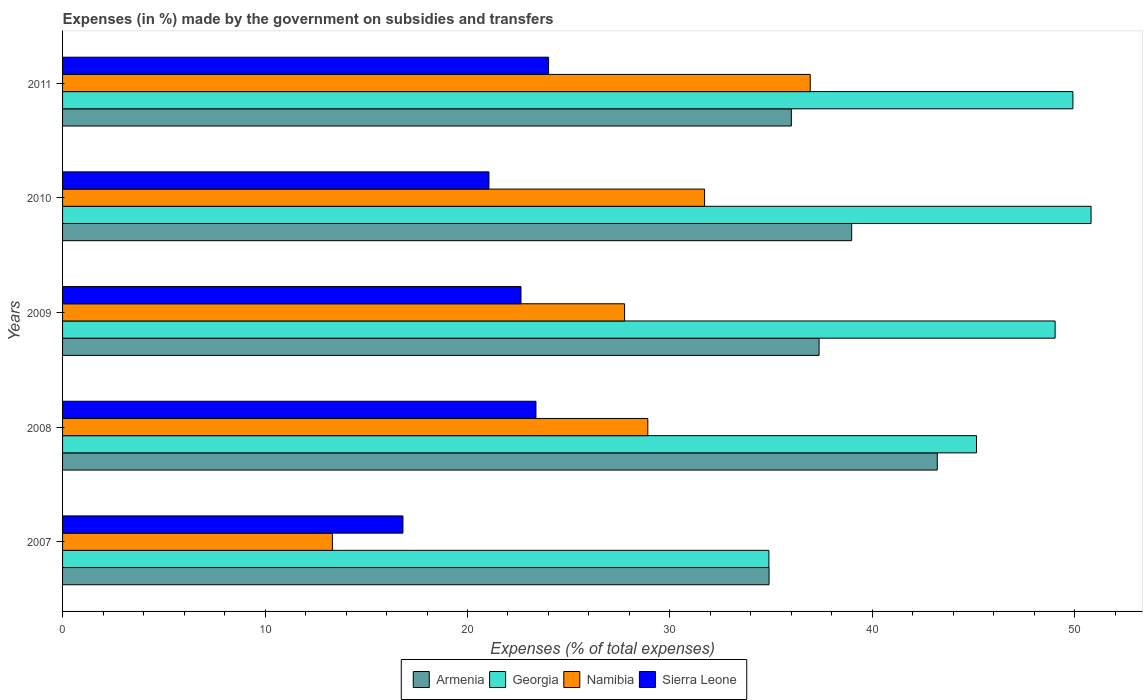How many groups of bars are there?
Give a very brief answer. 5. How many bars are there on the 2nd tick from the top?
Give a very brief answer. 4. What is the label of the 3rd group of bars from the top?
Your answer should be very brief. 2009. In how many cases, is the number of bars for a given year not equal to the number of legend labels?
Give a very brief answer. 0. What is the percentage of expenses made by the government on subsidies and transfers in Georgia in 2007?
Give a very brief answer. 34.89. Across all years, what is the maximum percentage of expenses made by the government on subsidies and transfers in Armenia?
Offer a terse response. 43.2. Across all years, what is the minimum percentage of expenses made by the government on subsidies and transfers in Namibia?
Your answer should be very brief. 13.33. In which year was the percentage of expenses made by the government on subsidies and transfers in Sierra Leone maximum?
Make the answer very short. 2011. In which year was the percentage of expenses made by the government on subsidies and transfers in Namibia minimum?
Ensure brevity in your answer.  2007. What is the total percentage of expenses made by the government on subsidies and transfers in Sierra Leone in the graph?
Keep it short and to the point. 107.9. What is the difference between the percentage of expenses made by the government on subsidies and transfers in Armenia in 2008 and that in 2010?
Provide a short and direct response. 4.23. What is the difference between the percentage of expenses made by the government on subsidies and transfers in Sierra Leone in 2009 and the percentage of expenses made by the government on subsidies and transfers in Armenia in 2008?
Your answer should be compact. -20.56. What is the average percentage of expenses made by the government on subsidies and transfers in Namibia per year?
Keep it short and to the point. 27.73. In the year 2008, what is the difference between the percentage of expenses made by the government on subsidies and transfers in Namibia and percentage of expenses made by the government on subsidies and transfers in Sierra Leone?
Ensure brevity in your answer.  5.52. In how many years, is the percentage of expenses made by the government on subsidies and transfers in Georgia greater than 24 %?
Provide a succinct answer. 5. What is the ratio of the percentage of expenses made by the government on subsidies and transfers in Georgia in 2007 to that in 2011?
Offer a very short reply. 0.7. What is the difference between the highest and the second highest percentage of expenses made by the government on subsidies and transfers in Sierra Leone?
Keep it short and to the point. 0.62. What is the difference between the highest and the lowest percentage of expenses made by the government on subsidies and transfers in Namibia?
Make the answer very short. 23.6. In how many years, is the percentage of expenses made by the government on subsidies and transfers in Armenia greater than the average percentage of expenses made by the government on subsidies and transfers in Armenia taken over all years?
Keep it short and to the point. 2. What does the 3rd bar from the top in 2008 represents?
Your answer should be compact. Georgia. What does the 1st bar from the bottom in 2009 represents?
Offer a terse response. Armenia. Is it the case that in every year, the sum of the percentage of expenses made by the government on subsidies and transfers in Namibia and percentage of expenses made by the government on subsidies and transfers in Georgia is greater than the percentage of expenses made by the government on subsidies and transfers in Armenia?
Your answer should be very brief. Yes. How many bars are there?
Provide a succinct answer. 20. Are all the bars in the graph horizontal?
Provide a succinct answer. Yes. What is the difference between two consecutive major ticks on the X-axis?
Offer a very short reply. 10. Does the graph contain grids?
Offer a terse response. No. Where does the legend appear in the graph?
Provide a short and direct response. Bottom center. What is the title of the graph?
Your answer should be very brief. Expenses (in %) made by the government on subsidies and transfers. What is the label or title of the X-axis?
Offer a very short reply. Expenses (% of total expenses). What is the label or title of the Y-axis?
Offer a terse response. Years. What is the Expenses (% of total expenses) in Armenia in 2007?
Your answer should be very brief. 34.89. What is the Expenses (% of total expenses) of Georgia in 2007?
Ensure brevity in your answer.  34.89. What is the Expenses (% of total expenses) of Namibia in 2007?
Your response must be concise. 13.33. What is the Expenses (% of total expenses) of Sierra Leone in 2007?
Ensure brevity in your answer.  16.81. What is the Expenses (% of total expenses) of Armenia in 2008?
Offer a terse response. 43.2. What is the Expenses (% of total expenses) of Georgia in 2008?
Offer a terse response. 45.14. What is the Expenses (% of total expenses) in Namibia in 2008?
Offer a very short reply. 28.91. What is the Expenses (% of total expenses) in Sierra Leone in 2008?
Offer a terse response. 23.38. What is the Expenses (% of total expenses) in Armenia in 2009?
Offer a terse response. 37.37. What is the Expenses (% of total expenses) in Georgia in 2009?
Give a very brief answer. 49.03. What is the Expenses (% of total expenses) in Namibia in 2009?
Provide a short and direct response. 27.76. What is the Expenses (% of total expenses) of Sierra Leone in 2009?
Make the answer very short. 22.64. What is the Expenses (% of total expenses) in Armenia in 2010?
Provide a short and direct response. 38.98. What is the Expenses (% of total expenses) in Georgia in 2010?
Give a very brief answer. 50.8. What is the Expenses (% of total expenses) in Namibia in 2010?
Keep it short and to the point. 31.71. What is the Expenses (% of total expenses) of Sierra Leone in 2010?
Your answer should be compact. 21.06. What is the Expenses (% of total expenses) in Armenia in 2011?
Ensure brevity in your answer.  36. What is the Expenses (% of total expenses) in Georgia in 2011?
Provide a short and direct response. 49.9. What is the Expenses (% of total expenses) in Namibia in 2011?
Give a very brief answer. 36.93. What is the Expenses (% of total expenses) in Sierra Leone in 2011?
Provide a short and direct response. 24.01. Across all years, what is the maximum Expenses (% of total expenses) of Armenia?
Your answer should be compact. 43.2. Across all years, what is the maximum Expenses (% of total expenses) in Georgia?
Provide a succinct answer. 50.8. Across all years, what is the maximum Expenses (% of total expenses) in Namibia?
Your response must be concise. 36.93. Across all years, what is the maximum Expenses (% of total expenses) of Sierra Leone?
Give a very brief answer. 24.01. Across all years, what is the minimum Expenses (% of total expenses) of Armenia?
Provide a short and direct response. 34.89. Across all years, what is the minimum Expenses (% of total expenses) in Georgia?
Offer a very short reply. 34.89. Across all years, what is the minimum Expenses (% of total expenses) in Namibia?
Ensure brevity in your answer.  13.33. Across all years, what is the minimum Expenses (% of total expenses) of Sierra Leone?
Your answer should be compact. 16.81. What is the total Expenses (% of total expenses) of Armenia in the graph?
Provide a succinct answer. 190.44. What is the total Expenses (% of total expenses) of Georgia in the graph?
Provide a succinct answer. 229.76. What is the total Expenses (% of total expenses) of Namibia in the graph?
Give a very brief answer. 138.63. What is the total Expenses (% of total expenses) of Sierra Leone in the graph?
Provide a succinct answer. 107.9. What is the difference between the Expenses (% of total expenses) of Armenia in 2007 and that in 2008?
Your response must be concise. -8.31. What is the difference between the Expenses (% of total expenses) in Georgia in 2007 and that in 2008?
Your answer should be compact. -10.26. What is the difference between the Expenses (% of total expenses) in Namibia in 2007 and that in 2008?
Provide a short and direct response. -15.58. What is the difference between the Expenses (% of total expenses) of Sierra Leone in 2007 and that in 2008?
Your answer should be compact. -6.57. What is the difference between the Expenses (% of total expenses) of Armenia in 2007 and that in 2009?
Provide a succinct answer. -2.47. What is the difference between the Expenses (% of total expenses) of Georgia in 2007 and that in 2009?
Provide a succinct answer. -14.14. What is the difference between the Expenses (% of total expenses) in Namibia in 2007 and that in 2009?
Keep it short and to the point. -14.43. What is the difference between the Expenses (% of total expenses) of Sierra Leone in 2007 and that in 2009?
Keep it short and to the point. -5.83. What is the difference between the Expenses (% of total expenses) of Armenia in 2007 and that in 2010?
Your answer should be very brief. -4.08. What is the difference between the Expenses (% of total expenses) of Georgia in 2007 and that in 2010?
Give a very brief answer. -15.91. What is the difference between the Expenses (% of total expenses) of Namibia in 2007 and that in 2010?
Your response must be concise. -18.38. What is the difference between the Expenses (% of total expenses) in Sierra Leone in 2007 and that in 2010?
Give a very brief answer. -4.25. What is the difference between the Expenses (% of total expenses) in Armenia in 2007 and that in 2011?
Offer a very short reply. -1.1. What is the difference between the Expenses (% of total expenses) of Georgia in 2007 and that in 2011?
Your response must be concise. -15.02. What is the difference between the Expenses (% of total expenses) of Namibia in 2007 and that in 2011?
Provide a short and direct response. -23.6. What is the difference between the Expenses (% of total expenses) of Sierra Leone in 2007 and that in 2011?
Provide a succinct answer. -7.19. What is the difference between the Expenses (% of total expenses) of Armenia in 2008 and that in 2009?
Give a very brief answer. 5.84. What is the difference between the Expenses (% of total expenses) in Georgia in 2008 and that in 2009?
Offer a terse response. -3.88. What is the difference between the Expenses (% of total expenses) of Namibia in 2008 and that in 2009?
Your answer should be very brief. 1.15. What is the difference between the Expenses (% of total expenses) of Sierra Leone in 2008 and that in 2009?
Ensure brevity in your answer.  0.74. What is the difference between the Expenses (% of total expenses) of Armenia in 2008 and that in 2010?
Provide a succinct answer. 4.23. What is the difference between the Expenses (% of total expenses) of Georgia in 2008 and that in 2010?
Keep it short and to the point. -5.66. What is the difference between the Expenses (% of total expenses) in Namibia in 2008 and that in 2010?
Offer a terse response. -2.8. What is the difference between the Expenses (% of total expenses) in Sierra Leone in 2008 and that in 2010?
Offer a terse response. 2.32. What is the difference between the Expenses (% of total expenses) of Armenia in 2008 and that in 2011?
Make the answer very short. 7.21. What is the difference between the Expenses (% of total expenses) of Georgia in 2008 and that in 2011?
Your response must be concise. -4.76. What is the difference between the Expenses (% of total expenses) in Namibia in 2008 and that in 2011?
Ensure brevity in your answer.  -8.02. What is the difference between the Expenses (% of total expenses) of Sierra Leone in 2008 and that in 2011?
Your response must be concise. -0.62. What is the difference between the Expenses (% of total expenses) of Armenia in 2009 and that in 2010?
Your response must be concise. -1.61. What is the difference between the Expenses (% of total expenses) of Georgia in 2009 and that in 2010?
Make the answer very short. -1.78. What is the difference between the Expenses (% of total expenses) in Namibia in 2009 and that in 2010?
Your answer should be compact. -3.95. What is the difference between the Expenses (% of total expenses) of Sierra Leone in 2009 and that in 2010?
Your response must be concise. 1.58. What is the difference between the Expenses (% of total expenses) of Armenia in 2009 and that in 2011?
Offer a very short reply. 1.37. What is the difference between the Expenses (% of total expenses) of Georgia in 2009 and that in 2011?
Make the answer very short. -0.88. What is the difference between the Expenses (% of total expenses) in Namibia in 2009 and that in 2011?
Offer a terse response. -9.17. What is the difference between the Expenses (% of total expenses) in Sierra Leone in 2009 and that in 2011?
Provide a succinct answer. -1.36. What is the difference between the Expenses (% of total expenses) in Armenia in 2010 and that in 2011?
Ensure brevity in your answer.  2.98. What is the difference between the Expenses (% of total expenses) in Georgia in 2010 and that in 2011?
Provide a succinct answer. 0.9. What is the difference between the Expenses (% of total expenses) in Namibia in 2010 and that in 2011?
Make the answer very short. -5.22. What is the difference between the Expenses (% of total expenses) in Sierra Leone in 2010 and that in 2011?
Give a very brief answer. -2.95. What is the difference between the Expenses (% of total expenses) of Armenia in 2007 and the Expenses (% of total expenses) of Georgia in 2008?
Your response must be concise. -10.25. What is the difference between the Expenses (% of total expenses) of Armenia in 2007 and the Expenses (% of total expenses) of Namibia in 2008?
Your response must be concise. 5.99. What is the difference between the Expenses (% of total expenses) of Armenia in 2007 and the Expenses (% of total expenses) of Sierra Leone in 2008?
Keep it short and to the point. 11.51. What is the difference between the Expenses (% of total expenses) of Georgia in 2007 and the Expenses (% of total expenses) of Namibia in 2008?
Ensure brevity in your answer.  5.98. What is the difference between the Expenses (% of total expenses) of Georgia in 2007 and the Expenses (% of total expenses) of Sierra Leone in 2008?
Offer a terse response. 11.5. What is the difference between the Expenses (% of total expenses) in Namibia in 2007 and the Expenses (% of total expenses) in Sierra Leone in 2008?
Offer a terse response. -10.06. What is the difference between the Expenses (% of total expenses) of Armenia in 2007 and the Expenses (% of total expenses) of Georgia in 2009?
Give a very brief answer. -14.13. What is the difference between the Expenses (% of total expenses) in Armenia in 2007 and the Expenses (% of total expenses) in Namibia in 2009?
Give a very brief answer. 7.13. What is the difference between the Expenses (% of total expenses) of Armenia in 2007 and the Expenses (% of total expenses) of Sierra Leone in 2009?
Provide a succinct answer. 12.25. What is the difference between the Expenses (% of total expenses) in Georgia in 2007 and the Expenses (% of total expenses) in Namibia in 2009?
Keep it short and to the point. 7.13. What is the difference between the Expenses (% of total expenses) in Georgia in 2007 and the Expenses (% of total expenses) in Sierra Leone in 2009?
Make the answer very short. 12.25. What is the difference between the Expenses (% of total expenses) of Namibia in 2007 and the Expenses (% of total expenses) of Sierra Leone in 2009?
Offer a terse response. -9.31. What is the difference between the Expenses (% of total expenses) in Armenia in 2007 and the Expenses (% of total expenses) in Georgia in 2010?
Offer a very short reply. -15.91. What is the difference between the Expenses (% of total expenses) in Armenia in 2007 and the Expenses (% of total expenses) in Namibia in 2010?
Make the answer very short. 3.18. What is the difference between the Expenses (% of total expenses) in Armenia in 2007 and the Expenses (% of total expenses) in Sierra Leone in 2010?
Provide a short and direct response. 13.84. What is the difference between the Expenses (% of total expenses) of Georgia in 2007 and the Expenses (% of total expenses) of Namibia in 2010?
Your answer should be very brief. 3.18. What is the difference between the Expenses (% of total expenses) of Georgia in 2007 and the Expenses (% of total expenses) of Sierra Leone in 2010?
Make the answer very short. 13.83. What is the difference between the Expenses (% of total expenses) of Namibia in 2007 and the Expenses (% of total expenses) of Sierra Leone in 2010?
Keep it short and to the point. -7.73. What is the difference between the Expenses (% of total expenses) of Armenia in 2007 and the Expenses (% of total expenses) of Georgia in 2011?
Keep it short and to the point. -15.01. What is the difference between the Expenses (% of total expenses) of Armenia in 2007 and the Expenses (% of total expenses) of Namibia in 2011?
Make the answer very short. -2.03. What is the difference between the Expenses (% of total expenses) of Armenia in 2007 and the Expenses (% of total expenses) of Sierra Leone in 2011?
Provide a short and direct response. 10.89. What is the difference between the Expenses (% of total expenses) in Georgia in 2007 and the Expenses (% of total expenses) in Namibia in 2011?
Offer a very short reply. -2.04. What is the difference between the Expenses (% of total expenses) of Georgia in 2007 and the Expenses (% of total expenses) of Sierra Leone in 2011?
Your response must be concise. 10.88. What is the difference between the Expenses (% of total expenses) of Namibia in 2007 and the Expenses (% of total expenses) of Sierra Leone in 2011?
Make the answer very short. -10.68. What is the difference between the Expenses (% of total expenses) of Armenia in 2008 and the Expenses (% of total expenses) of Georgia in 2009?
Give a very brief answer. -5.82. What is the difference between the Expenses (% of total expenses) of Armenia in 2008 and the Expenses (% of total expenses) of Namibia in 2009?
Provide a succinct answer. 15.44. What is the difference between the Expenses (% of total expenses) in Armenia in 2008 and the Expenses (% of total expenses) in Sierra Leone in 2009?
Give a very brief answer. 20.56. What is the difference between the Expenses (% of total expenses) of Georgia in 2008 and the Expenses (% of total expenses) of Namibia in 2009?
Ensure brevity in your answer.  17.38. What is the difference between the Expenses (% of total expenses) of Georgia in 2008 and the Expenses (% of total expenses) of Sierra Leone in 2009?
Make the answer very short. 22.5. What is the difference between the Expenses (% of total expenses) in Namibia in 2008 and the Expenses (% of total expenses) in Sierra Leone in 2009?
Your answer should be compact. 6.26. What is the difference between the Expenses (% of total expenses) in Armenia in 2008 and the Expenses (% of total expenses) in Georgia in 2010?
Offer a terse response. -7.6. What is the difference between the Expenses (% of total expenses) in Armenia in 2008 and the Expenses (% of total expenses) in Namibia in 2010?
Make the answer very short. 11.49. What is the difference between the Expenses (% of total expenses) of Armenia in 2008 and the Expenses (% of total expenses) of Sierra Leone in 2010?
Offer a terse response. 22.14. What is the difference between the Expenses (% of total expenses) of Georgia in 2008 and the Expenses (% of total expenses) of Namibia in 2010?
Provide a short and direct response. 13.43. What is the difference between the Expenses (% of total expenses) in Georgia in 2008 and the Expenses (% of total expenses) in Sierra Leone in 2010?
Your response must be concise. 24.08. What is the difference between the Expenses (% of total expenses) in Namibia in 2008 and the Expenses (% of total expenses) in Sierra Leone in 2010?
Your answer should be compact. 7.85. What is the difference between the Expenses (% of total expenses) in Armenia in 2008 and the Expenses (% of total expenses) in Georgia in 2011?
Offer a very short reply. -6.7. What is the difference between the Expenses (% of total expenses) of Armenia in 2008 and the Expenses (% of total expenses) of Namibia in 2011?
Your response must be concise. 6.27. What is the difference between the Expenses (% of total expenses) in Armenia in 2008 and the Expenses (% of total expenses) in Sierra Leone in 2011?
Give a very brief answer. 19.2. What is the difference between the Expenses (% of total expenses) of Georgia in 2008 and the Expenses (% of total expenses) of Namibia in 2011?
Make the answer very short. 8.21. What is the difference between the Expenses (% of total expenses) in Georgia in 2008 and the Expenses (% of total expenses) in Sierra Leone in 2011?
Give a very brief answer. 21.14. What is the difference between the Expenses (% of total expenses) of Namibia in 2008 and the Expenses (% of total expenses) of Sierra Leone in 2011?
Ensure brevity in your answer.  4.9. What is the difference between the Expenses (% of total expenses) in Armenia in 2009 and the Expenses (% of total expenses) in Georgia in 2010?
Ensure brevity in your answer.  -13.43. What is the difference between the Expenses (% of total expenses) in Armenia in 2009 and the Expenses (% of total expenses) in Namibia in 2010?
Provide a short and direct response. 5.66. What is the difference between the Expenses (% of total expenses) in Armenia in 2009 and the Expenses (% of total expenses) in Sierra Leone in 2010?
Offer a very short reply. 16.31. What is the difference between the Expenses (% of total expenses) of Georgia in 2009 and the Expenses (% of total expenses) of Namibia in 2010?
Offer a terse response. 17.31. What is the difference between the Expenses (% of total expenses) of Georgia in 2009 and the Expenses (% of total expenses) of Sierra Leone in 2010?
Give a very brief answer. 27.97. What is the difference between the Expenses (% of total expenses) of Namibia in 2009 and the Expenses (% of total expenses) of Sierra Leone in 2010?
Give a very brief answer. 6.7. What is the difference between the Expenses (% of total expenses) of Armenia in 2009 and the Expenses (% of total expenses) of Georgia in 2011?
Keep it short and to the point. -12.54. What is the difference between the Expenses (% of total expenses) of Armenia in 2009 and the Expenses (% of total expenses) of Namibia in 2011?
Ensure brevity in your answer.  0.44. What is the difference between the Expenses (% of total expenses) of Armenia in 2009 and the Expenses (% of total expenses) of Sierra Leone in 2011?
Offer a terse response. 13.36. What is the difference between the Expenses (% of total expenses) in Georgia in 2009 and the Expenses (% of total expenses) in Namibia in 2011?
Provide a short and direct response. 12.1. What is the difference between the Expenses (% of total expenses) in Georgia in 2009 and the Expenses (% of total expenses) in Sierra Leone in 2011?
Provide a succinct answer. 25.02. What is the difference between the Expenses (% of total expenses) of Namibia in 2009 and the Expenses (% of total expenses) of Sierra Leone in 2011?
Ensure brevity in your answer.  3.75. What is the difference between the Expenses (% of total expenses) in Armenia in 2010 and the Expenses (% of total expenses) in Georgia in 2011?
Your answer should be compact. -10.93. What is the difference between the Expenses (% of total expenses) in Armenia in 2010 and the Expenses (% of total expenses) in Namibia in 2011?
Your answer should be very brief. 2.05. What is the difference between the Expenses (% of total expenses) of Armenia in 2010 and the Expenses (% of total expenses) of Sierra Leone in 2011?
Your answer should be very brief. 14.97. What is the difference between the Expenses (% of total expenses) of Georgia in 2010 and the Expenses (% of total expenses) of Namibia in 2011?
Offer a very short reply. 13.87. What is the difference between the Expenses (% of total expenses) of Georgia in 2010 and the Expenses (% of total expenses) of Sierra Leone in 2011?
Offer a very short reply. 26.79. What is the difference between the Expenses (% of total expenses) of Namibia in 2010 and the Expenses (% of total expenses) of Sierra Leone in 2011?
Give a very brief answer. 7.7. What is the average Expenses (% of total expenses) of Armenia per year?
Your answer should be compact. 38.09. What is the average Expenses (% of total expenses) in Georgia per year?
Offer a terse response. 45.95. What is the average Expenses (% of total expenses) of Namibia per year?
Your answer should be compact. 27.73. What is the average Expenses (% of total expenses) in Sierra Leone per year?
Your response must be concise. 21.58. In the year 2007, what is the difference between the Expenses (% of total expenses) in Armenia and Expenses (% of total expenses) in Georgia?
Offer a very short reply. 0.01. In the year 2007, what is the difference between the Expenses (% of total expenses) in Armenia and Expenses (% of total expenses) in Namibia?
Keep it short and to the point. 21.57. In the year 2007, what is the difference between the Expenses (% of total expenses) in Armenia and Expenses (% of total expenses) in Sierra Leone?
Ensure brevity in your answer.  18.08. In the year 2007, what is the difference between the Expenses (% of total expenses) in Georgia and Expenses (% of total expenses) in Namibia?
Provide a succinct answer. 21.56. In the year 2007, what is the difference between the Expenses (% of total expenses) of Georgia and Expenses (% of total expenses) of Sierra Leone?
Offer a very short reply. 18.07. In the year 2007, what is the difference between the Expenses (% of total expenses) of Namibia and Expenses (% of total expenses) of Sierra Leone?
Your answer should be compact. -3.48. In the year 2008, what is the difference between the Expenses (% of total expenses) of Armenia and Expenses (% of total expenses) of Georgia?
Your answer should be compact. -1.94. In the year 2008, what is the difference between the Expenses (% of total expenses) in Armenia and Expenses (% of total expenses) in Namibia?
Your answer should be compact. 14.3. In the year 2008, what is the difference between the Expenses (% of total expenses) of Armenia and Expenses (% of total expenses) of Sierra Leone?
Offer a very short reply. 19.82. In the year 2008, what is the difference between the Expenses (% of total expenses) of Georgia and Expenses (% of total expenses) of Namibia?
Provide a succinct answer. 16.24. In the year 2008, what is the difference between the Expenses (% of total expenses) of Georgia and Expenses (% of total expenses) of Sierra Leone?
Provide a short and direct response. 21.76. In the year 2008, what is the difference between the Expenses (% of total expenses) of Namibia and Expenses (% of total expenses) of Sierra Leone?
Offer a terse response. 5.52. In the year 2009, what is the difference between the Expenses (% of total expenses) of Armenia and Expenses (% of total expenses) of Georgia?
Your answer should be compact. -11.66. In the year 2009, what is the difference between the Expenses (% of total expenses) of Armenia and Expenses (% of total expenses) of Namibia?
Your response must be concise. 9.61. In the year 2009, what is the difference between the Expenses (% of total expenses) in Armenia and Expenses (% of total expenses) in Sierra Leone?
Make the answer very short. 14.72. In the year 2009, what is the difference between the Expenses (% of total expenses) in Georgia and Expenses (% of total expenses) in Namibia?
Your answer should be very brief. 21.27. In the year 2009, what is the difference between the Expenses (% of total expenses) of Georgia and Expenses (% of total expenses) of Sierra Leone?
Ensure brevity in your answer.  26.38. In the year 2009, what is the difference between the Expenses (% of total expenses) in Namibia and Expenses (% of total expenses) in Sierra Leone?
Your answer should be compact. 5.12. In the year 2010, what is the difference between the Expenses (% of total expenses) in Armenia and Expenses (% of total expenses) in Georgia?
Offer a very short reply. -11.82. In the year 2010, what is the difference between the Expenses (% of total expenses) of Armenia and Expenses (% of total expenses) of Namibia?
Your answer should be compact. 7.27. In the year 2010, what is the difference between the Expenses (% of total expenses) in Armenia and Expenses (% of total expenses) in Sierra Leone?
Offer a terse response. 17.92. In the year 2010, what is the difference between the Expenses (% of total expenses) in Georgia and Expenses (% of total expenses) in Namibia?
Your answer should be compact. 19.09. In the year 2010, what is the difference between the Expenses (% of total expenses) of Georgia and Expenses (% of total expenses) of Sierra Leone?
Keep it short and to the point. 29.74. In the year 2010, what is the difference between the Expenses (% of total expenses) of Namibia and Expenses (% of total expenses) of Sierra Leone?
Your answer should be compact. 10.65. In the year 2011, what is the difference between the Expenses (% of total expenses) of Armenia and Expenses (% of total expenses) of Georgia?
Provide a succinct answer. -13.91. In the year 2011, what is the difference between the Expenses (% of total expenses) of Armenia and Expenses (% of total expenses) of Namibia?
Keep it short and to the point. -0.93. In the year 2011, what is the difference between the Expenses (% of total expenses) in Armenia and Expenses (% of total expenses) in Sierra Leone?
Provide a succinct answer. 11.99. In the year 2011, what is the difference between the Expenses (% of total expenses) of Georgia and Expenses (% of total expenses) of Namibia?
Provide a succinct answer. 12.97. In the year 2011, what is the difference between the Expenses (% of total expenses) in Georgia and Expenses (% of total expenses) in Sierra Leone?
Offer a terse response. 25.9. In the year 2011, what is the difference between the Expenses (% of total expenses) in Namibia and Expenses (% of total expenses) in Sierra Leone?
Your response must be concise. 12.92. What is the ratio of the Expenses (% of total expenses) of Armenia in 2007 to that in 2008?
Provide a succinct answer. 0.81. What is the ratio of the Expenses (% of total expenses) of Georgia in 2007 to that in 2008?
Ensure brevity in your answer.  0.77. What is the ratio of the Expenses (% of total expenses) in Namibia in 2007 to that in 2008?
Offer a very short reply. 0.46. What is the ratio of the Expenses (% of total expenses) in Sierra Leone in 2007 to that in 2008?
Give a very brief answer. 0.72. What is the ratio of the Expenses (% of total expenses) in Armenia in 2007 to that in 2009?
Provide a succinct answer. 0.93. What is the ratio of the Expenses (% of total expenses) in Georgia in 2007 to that in 2009?
Your answer should be very brief. 0.71. What is the ratio of the Expenses (% of total expenses) in Namibia in 2007 to that in 2009?
Give a very brief answer. 0.48. What is the ratio of the Expenses (% of total expenses) of Sierra Leone in 2007 to that in 2009?
Provide a short and direct response. 0.74. What is the ratio of the Expenses (% of total expenses) of Armenia in 2007 to that in 2010?
Offer a terse response. 0.9. What is the ratio of the Expenses (% of total expenses) in Georgia in 2007 to that in 2010?
Your answer should be compact. 0.69. What is the ratio of the Expenses (% of total expenses) in Namibia in 2007 to that in 2010?
Give a very brief answer. 0.42. What is the ratio of the Expenses (% of total expenses) in Sierra Leone in 2007 to that in 2010?
Ensure brevity in your answer.  0.8. What is the ratio of the Expenses (% of total expenses) of Armenia in 2007 to that in 2011?
Your response must be concise. 0.97. What is the ratio of the Expenses (% of total expenses) of Georgia in 2007 to that in 2011?
Your response must be concise. 0.7. What is the ratio of the Expenses (% of total expenses) of Namibia in 2007 to that in 2011?
Give a very brief answer. 0.36. What is the ratio of the Expenses (% of total expenses) of Sierra Leone in 2007 to that in 2011?
Provide a short and direct response. 0.7. What is the ratio of the Expenses (% of total expenses) of Armenia in 2008 to that in 2009?
Ensure brevity in your answer.  1.16. What is the ratio of the Expenses (% of total expenses) in Georgia in 2008 to that in 2009?
Your response must be concise. 0.92. What is the ratio of the Expenses (% of total expenses) of Namibia in 2008 to that in 2009?
Your response must be concise. 1.04. What is the ratio of the Expenses (% of total expenses) in Sierra Leone in 2008 to that in 2009?
Your answer should be compact. 1.03. What is the ratio of the Expenses (% of total expenses) of Armenia in 2008 to that in 2010?
Give a very brief answer. 1.11. What is the ratio of the Expenses (% of total expenses) of Georgia in 2008 to that in 2010?
Ensure brevity in your answer.  0.89. What is the ratio of the Expenses (% of total expenses) of Namibia in 2008 to that in 2010?
Give a very brief answer. 0.91. What is the ratio of the Expenses (% of total expenses) in Sierra Leone in 2008 to that in 2010?
Give a very brief answer. 1.11. What is the ratio of the Expenses (% of total expenses) of Armenia in 2008 to that in 2011?
Your answer should be very brief. 1.2. What is the ratio of the Expenses (% of total expenses) of Georgia in 2008 to that in 2011?
Your answer should be compact. 0.9. What is the ratio of the Expenses (% of total expenses) of Namibia in 2008 to that in 2011?
Provide a short and direct response. 0.78. What is the ratio of the Expenses (% of total expenses) of Armenia in 2009 to that in 2010?
Give a very brief answer. 0.96. What is the ratio of the Expenses (% of total expenses) of Georgia in 2009 to that in 2010?
Your answer should be compact. 0.97. What is the ratio of the Expenses (% of total expenses) of Namibia in 2009 to that in 2010?
Your response must be concise. 0.88. What is the ratio of the Expenses (% of total expenses) in Sierra Leone in 2009 to that in 2010?
Make the answer very short. 1.08. What is the ratio of the Expenses (% of total expenses) of Armenia in 2009 to that in 2011?
Provide a succinct answer. 1.04. What is the ratio of the Expenses (% of total expenses) of Georgia in 2009 to that in 2011?
Give a very brief answer. 0.98. What is the ratio of the Expenses (% of total expenses) of Namibia in 2009 to that in 2011?
Your response must be concise. 0.75. What is the ratio of the Expenses (% of total expenses) of Sierra Leone in 2009 to that in 2011?
Make the answer very short. 0.94. What is the ratio of the Expenses (% of total expenses) of Armenia in 2010 to that in 2011?
Offer a very short reply. 1.08. What is the ratio of the Expenses (% of total expenses) in Namibia in 2010 to that in 2011?
Your answer should be very brief. 0.86. What is the ratio of the Expenses (% of total expenses) of Sierra Leone in 2010 to that in 2011?
Keep it short and to the point. 0.88. What is the difference between the highest and the second highest Expenses (% of total expenses) of Armenia?
Your answer should be very brief. 4.23. What is the difference between the highest and the second highest Expenses (% of total expenses) of Georgia?
Your response must be concise. 0.9. What is the difference between the highest and the second highest Expenses (% of total expenses) in Namibia?
Keep it short and to the point. 5.22. What is the difference between the highest and the second highest Expenses (% of total expenses) in Sierra Leone?
Offer a very short reply. 0.62. What is the difference between the highest and the lowest Expenses (% of total expenses) of Armenia?
Your answer should be very brief. 8.31. What is the difference between the highest and the lowest Expenses (% of total expenses) in Georgia?
Give a very brief answer. 15.91. What is the difference between the highest and the lowest Expenses (% of total expenses) of Namibia?
Offer a terse response. 23.6. What is the difference between the highest and the lowest Expenses (% of total expenses) of Sierra Leone?
Ensure brevity in your answer.  7.19. 